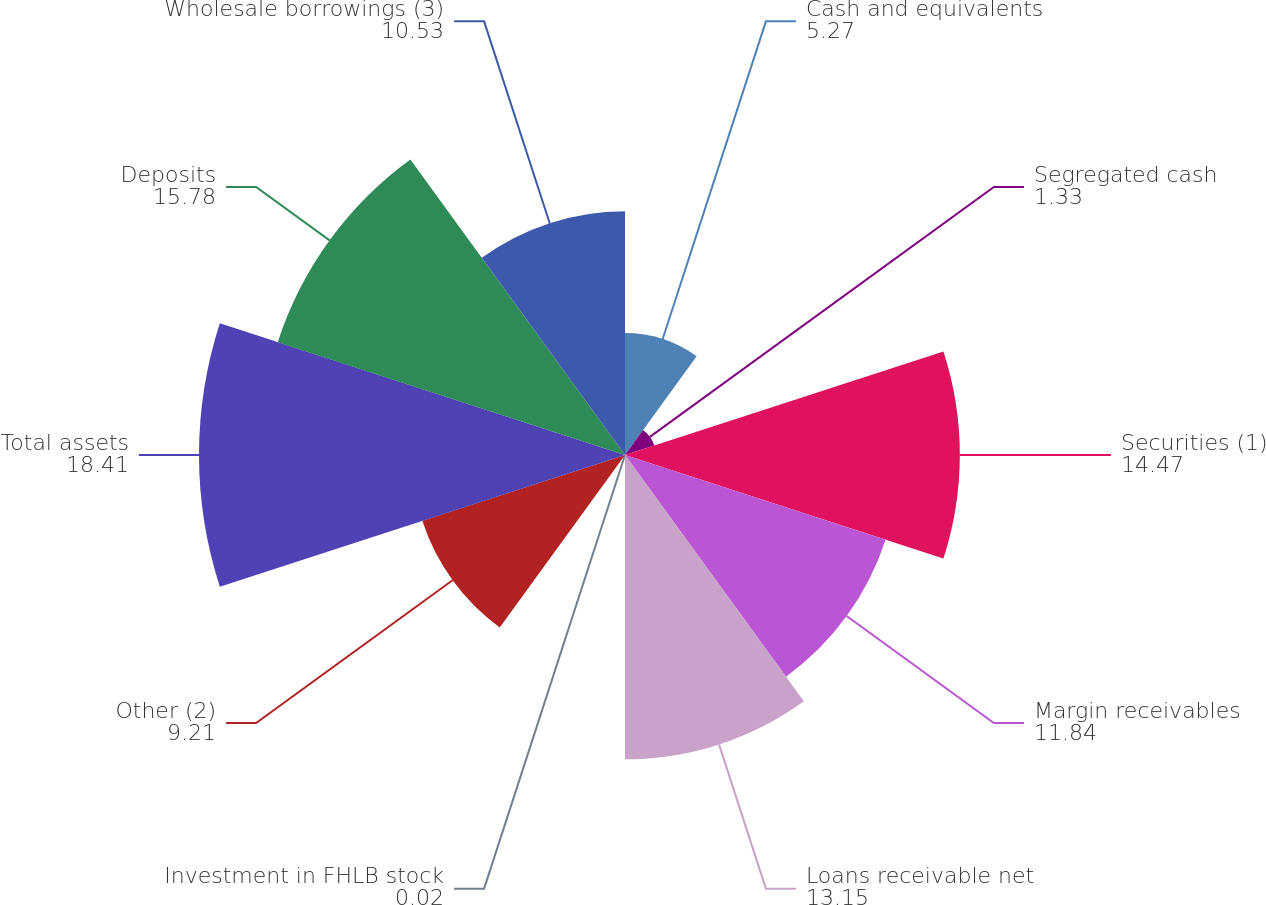<chart> <loc_0><loc_0><loc_500><loc_500><pie_chart><fcel>Cash and equivalents<fcel>Segregated cash<fcel>Securities (1)<fcel>Margin receivables<fcel>Loans receivable net<fcel>Investment in FHLB stock<fcel>Other (2)<fcel>Total assets<fcel>Deposits<fcel>Wholesale borrowings (3)<nl><fcel>5.27%<fcel>1.33%<fcel>14.47%<fcel>11.84%<fcel>13.15%<fcel>0.02%<fcel>9.21%<fcel>18.41%<fcel>15.78%<fcel>10.53%<nl></chart> 